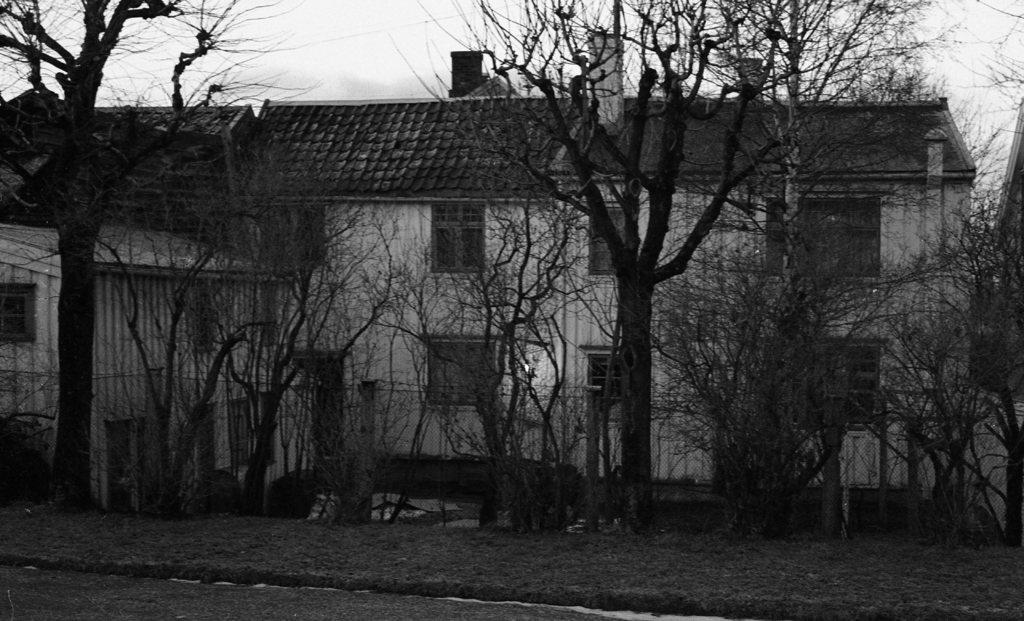What structures are located in the middle of the image? There are buildings in the middle of the image. What type of vegetation is in front of the buildings? There are trees in front of the buildings. What is the color scheme of the image? The image is black and white. Where is the faucet located in the image? There is no faucet present in the image. Can you hear the sound of the dock in the image? There is no dock or sound present in the image, as it is a black and white image of buildings and trees. 